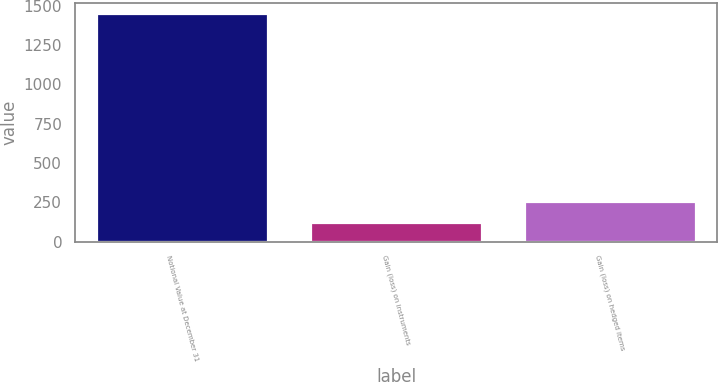Convert chart to OTSL. <chart><loc_0><loc_0><loc_500><loc_500><bar_chart><fcel>Notional Value at December 31<fcel>Gain (loss) on instruments<fcel>Gain (loss) on hedged items<nl><fcel>1445<fcel>121<fcel>253.4<nl></chart> 